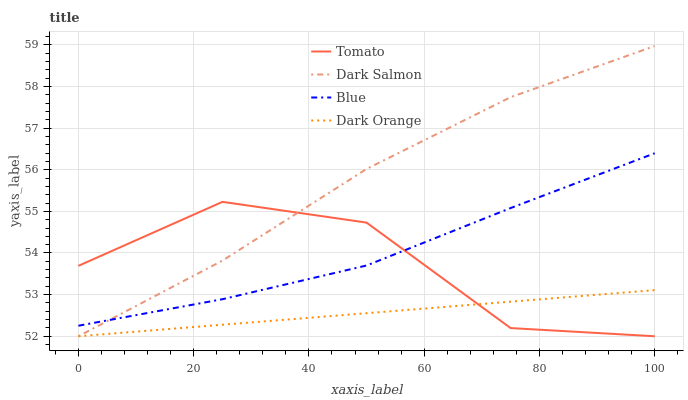Does Dark Orange have the minimum area under the curve?
Answer yes or no. Yes. Does Dark Salmon have the maximum area under the curve?
Answer yes or no. Yes. Does Blue have the minimum area under the curve?
Answer yes or no. No. Does Blue have the maximum area under the curve?
Answer yes or no. No. Is Dark Orange the smoothest?
Answer yes or no. Yes. Is Tomato the roughest?
Answer yes or no. Yes. Is Blue the smoothest?
Answer yes or no. No. Is Blue the roughest?
Answer yes or no. No. Does Tomato have the lowest value?
Answer yes or no. Yes. Does Blue have the lowest value?
Answer yes or no. No. Does Dark Salmon have the highest value?
Answer yes or no. Yes. Does Blue have the highest value?
Answer yes or no. No. Is Dark Orange less than Blue?
Answer yes or no. Yes. Is Blue greater than Dark Orange?
Answer yes or no. Yes. Does Dark Orange intersect Dark Salmon?
Answer yes or no. Yes. Is Dark Orange less than Dark Salmon?
Answer yes or no. No. Is Dark Orange greater than Dark Salmon?
Answer yes or no. No. Does Dark Orange intersect Blue?
Answer yes or no. No. 